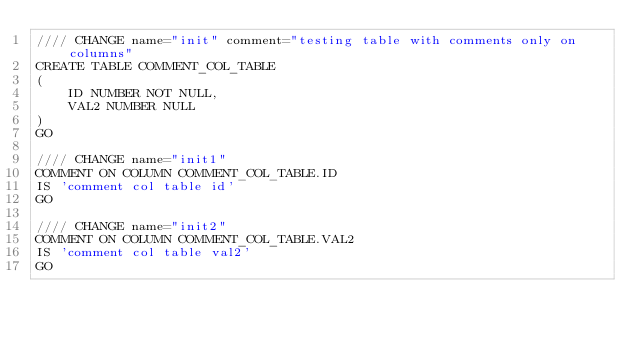<code> <loc_0><loc_0><loc_500><loc_500><_SQL_>//// CHANGE name="init" comment="testing table with comments only on columns"
CREATE TABLE COMMENT_COL_TABLE
(
    ID NUMBER NOT NULL,
    VAL2 NUMBER NULL
)
GO

//// CHANGE name="init1"
COMMENT ON COLUMN COMMENT_COL_TABLE.ID
IS 'comment col table id'
GO

//// CHANGE name="init2"
COMMENT ON COLUMN COMMENT_COL_TABLE.VAL2
IS 'comment col table val2'
GO
</code> 